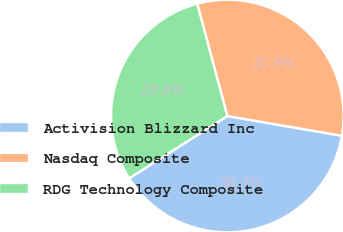Convert chart. <chart><loc_0><loc_0><loc_500><loc_500><pie_chart><fcel>Activision Blizzard Inc<fcel>Nasdaq Composite<fcel>RDG Technology Composite<nl><fcel>38.29%<fcel>31.88%<fcel>29.83%<nl></chart> 